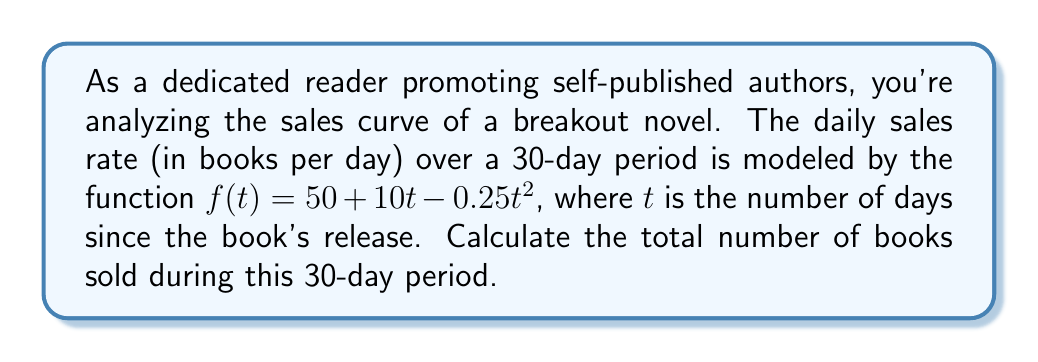Help me with this question. To find the total number of books sold, we need to calculate the area under the sales curve over the 30-day period. This can be done using definite integration.

1) The function representing daily sales is:
   $$f(t) = 50 + 10t - 0.25t^2$$

2) We need to integrate this function from $t=0$ to $t=30$:
   $$\int_0^{30} (50 + 10t - 0.25t^2) dt$$

3) Integrate each term:
   $$\left[50t + 5t^2 - \frac{1}{12}t^3\right]_0^{30}$$

4) Evaluate the antiderivative at the limits:
   $$\left(50(30) + 5(30^2) - \frac{1}{12}(30^3)\right) - \left(50(0) + 5(0^2) - \frac{1}{12}(0^3)\right)$$

5) Simplify:
   $$\left(1500 + 4500 - 2250\right) - 0 = 3750$$

Therefore, the total number of books sold over the 30-day period is 3,750.
Answer: 3,750 books 